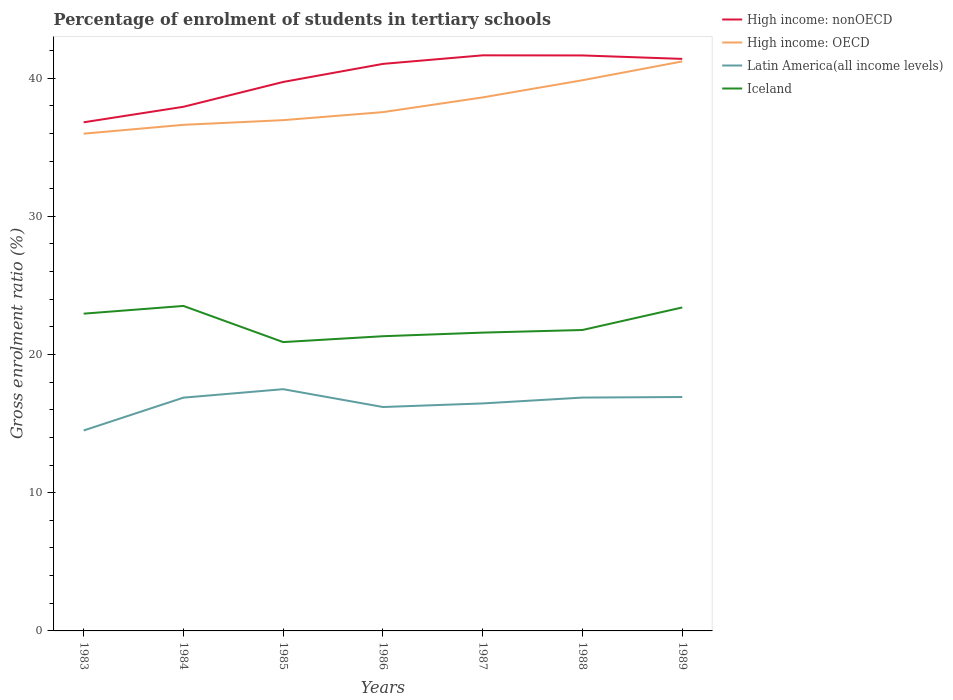Does the line corresponding to Iceland intersect with the line corresponding to High income: nonOECD?
Give a very brief answer. No. Is the number of lines equal to the number of legend labels?
Ensure brevity in your answer.  Yes. Across all years, what is the maximum percentage of students enrolled in tertiary schools in High income: nonOECD?
Your answer should be compact. 36.8. In which year was the percentage of students enrolled in tertiary schools in Iceland maximum?
Ensure brevity in your answer.  1985. What is the total percentage of students enrolled in tertiary schools in High income: OECD in the graph?
Make the answer very short. -0.92. What is the difference between the highest and the second highest percentage of students enrolled in tertiary schools in Latin America(all income levels)?
Your response must be concise. 2.99. How many years are there in the graph?
Your response must be concise. 7. Does the graph contain any zero values?
Your answer should be compact. No. Does the graph contain grids?
Give a very brief answer. No. What is the title of the graph?
Offer a very short reply. Percentage of enrolment of students in tertiary schools. What is the Gross enrolment ratio (%) of High income: nonOECD in 1983?
Give a very brief answer. 36.8. What is the Gross enrolment ratio (%) in High income: OECD in 1983?
Offer a very short reply. 35.98. What is the Gross enrolment ratio (%) in Latin America(all income levels) in 1983?
Offer a terse response. 14.5. What is the Gross enrolment ratio (%) of Iceland in 1983?
Offer a terse response. 22.96. What is the Gross enrolment ratio (%) in High income: nonOECD in 1984?
Your answer should be compact. 37.92. What is the Gross enrolment ratio (%) in High income: OECD in 1984?
Your answer should be very brief. 36.62. What is the Gross enrolment ratio (%) in Latin America(all income levels) in 1984?
Offer a very short reply. 16.88. What is the Gross enrolment ratio (%) of Iceland in 1984?
Provide a succinct answer. 23.51. What is the Gross enrolment ratio (%) of High income: nonOECD in 1985?
Keep it short and to the point. 39.72. What is the Gross enrolment ratio (%) of High income: OECD in 1985?
Make the answer very short. 36.96. What is the Gross enrolment ratio (%) of Latin America(all income levels) in 1985?
Make the answer very short. 17.49. What is the Gross enrolment ratio (%) of Iceland in 1985?
Make the answer very short. 20.9. What is the Gross enrolment ratio (%) of High income: nonOECD in 1986?
Your response must be concise. 41.03. What is the Gross enrolment ratio (%) of High income: OECD in 1986?
Provide a succinct answer. 37.54. What is the Gross enrolment ratio (%) in Latin America(all income levels) in 1986?
Offer a very short reply. 16.2. What is the Gross enrolment ratio (%) of Iceland in 1986?
Your response must be concise. 21.32. What is the Gross enrolment ratio (%) of High income: nonOECD in 1987?
Make the answer very short. 41.65. What is the Gross enrolment ratio (%) in High income: OECD in 1987?
Provide a succinct answer. 38.6. What is the Gross enrolment ratio (%) in Latin America(all income levels) in 1987?
Give a very brief answer. 16.46. What is the Gross enrolment ratio (%) in Iceland in 1987?
Your answer should be compact. 21.58. What is the Gross enrolment ratio (%) in High income: nonOECD in 1988?
Your answer should be very brief. 41.64. What is the Gross enrolment ratio (%) of High income: OECD in 1988?
Offer a terse response. 39.85. What is the Gross enrolment ratio (%) in Latin America(all income levels) in 1988?
Keep it short and to the point. 16.88. What is the Gross enrolment ratio (%) of Iceland in 1988?
Your answer should be very brief. 21.77. What is the Gross enrolment ratio (%) of High income: nonOECD in 1989?
Give a very brief answer. 41.39. What is the Gross enrolment ratio (%) of High income: OECD in 1989?
Your response must be concise. 41.21. What is the Gross enrolment ratio (%) of Latin America(all income levels) in 1989?
Give a very brief answer. 16.93. What is the Gross enrolment ratio (%) in Iceland in 1989?
Ensure brevity in your answer.  23.4. Across all years, what is the maximum Gross enrolment ratio (%) of High income: nonOECD?
Your answer should be compact. 41.65. Across all years, what is the maximum Gross enrolment ratio (%) in High income: OECD?
Keep it short and to the point. 41.21. Across all years, what is the maximum Gross enrolment ratio (%) in Latin America(all income levels)?
Your answer should be very brief. 17.49. Across all years, what is the maximum Gross enrolment ratio (%) in Iceland?
Give a very brief answer. 23.51. Across all years, what is the minimum Gross enrolment ratio (%) in High income: nonOECD?
Offer a very short reply. 36.8. Across all years, what is the minimum Gross enrolment ratio (%) of High income: OECD?
Provide a short and direct response. 35.98. Across all years, what is the minimum Gross enrolment ratio (%) in Latin America(all income levels)?
Offer a very short reply. 14.5. Across all years, what is the minimum Gross enrolment ratio (%) of Iceland?
Your answer should be very brief. 20.9. What is the total Gross enrolment ratio (%) of High income: nonOECD in the graph?
Provide a succinct answer. 280.15. What is the total Gross enrolment ratio (%) of High income: OECD in the graph?
Provide a short and direct response. 266.75. What is the total Gross enrolment ratio (%) of Latin America(all income levels) in the graph?
Make the answer very short. 115.35. What is the total Gross enrolment ratio (%) in Iceland in the graph?
Keep it short and to the point. 155.46. What is the difference between the Gross enrolment ratio (%) in High income: nonOECD in 1983 and that in 1984?
Offer a terse response. -1.12. What is the difference between the Gross enrolment ratio (%) in High income: OECD in 1983 and that in 1984?
Offer a very short reply. -0.64. What is the difference between the Gross enrolment ratio (%) of Latin America(all income levels) in 1983 and that in 1984?
Provide a short and direct response. -2.38. What is the difference between the Gross enrolment ratio (%) in Iceland in 1983 and that in 1984?
Make the answer very short. -0.56. What is the difference between the Gross enrolment ratio (%) of High income: nonOECD in 1983 and that in 1985?
Your answer should be very brief. -2.92. What is the difference between the Gross enrolment ratio (%) in High income: OECD in 1983 and that in 1985?
Ensure brevity in your answer.  -0.98. What is the difference between the Gross enrolment ratio (%) in Latin America(all income levels) in 1983 and that in 1985?
Ensure brevity in your answer.  -2.99. What is the difference between the Gross enrolment ratio (%) in Iceland in 1983 and that in 1985?
Provide a short and direct response. 2.06. What is the difference between the Gross enrolment ratio (%) of High income: nonOECD in 1983 and that in 1986?
Make the answer very short. -4.23. What is the difference between the Gross enrolment ratio (%) in High income: OECD in 1983 and that in 1986?
Provide a short and direct response. -1.56. What is the difference between the Gross enrolment ratio (%) of Latin America(all income levels) in 1983 and that in 1986?
Your answer should be compact. -1.7. What is the difference between the Gross enrolment ratio (%) of Iceland in 1983 and that in 1986?
Offer a terse response. 1.63. What is the difference between the Gross enrolment ratio (%) in High income: nonOECD in 1983 and that in 1987?
Your response must be concise. -4.85. What is the difference between the Gross enrolment ratio (%) of High income: OECD in 1983 and that in 1987?
Your answer should be very brief. -2.63. What is the difference between the Gross enrolment ratio (%) of Latin America(all income levels) in 1983 and that in 1987?
Your answer should be compact. -1.96. What is the difference between the Gross enrolment ratio (%) of Iceland in 1983 and that in 1987?
Offer a very short reply. 1.37. What is the difference between the Gross enrolment ratio (%) in High income: nonOECD in 1983 and that in 1988?
Provide a succinct answer. -4.84. What is the difference between the Gross enrolment ratio (%) of High income: OECD in 1983 and that in 1988?
Keep it short and to the point. -3.87. What is the difference between the Gross enrolment ratio (%) of Latin America(all income levels) in 1983 and that in 1988?
Your response must be concise. -2.38. What is the difference between the Gross enrolment ratio (%) of Iceland in 1983 and that in 1988?
Offer a very short reply. 1.18. What is the difference between the Gross enrolment ratio (%) of High income: nonOECD in 1983 and that in 1989?
Give a very brief answer. -4.59. What is the difference between the Gross enrolment ratio (%) of High income: OECD in 1983 and that in 1989?
Keep it short and to the point. -5.23. What is the difference between the Gross enrolment ratio (%) in Latin America(all income levels) in 1983 and that in 1989?
Provide a short and direct response. -2.42. What is the difference between the Gross enrolment ratio (%) in Iceland in 1983 and that in 1989?
Provide a short and direct response. -0.45. What is the difference between the Gross enrolment ratio (%) in High income: nonOECD in 1984 and that in 1985?
Offer a very short reply. -1.8. What is the difference between the Gross enrolment ratio (%) of High income: OECD in 1984 and that in 1985?
Offer a very short reply. -0.34. What is the difference between the Gross enrolment ratio (%) of Latin America(all income levels) in 1984 and that in 1985?
Your response must be concise. -0.61. What is the difference between the Gross enrolment ratio (%) in Iceland in 1984 and that in 1985?
Keep it short and to the point. 2.62. What is the difference between the Gross enrolment ratio (%) of High income: nonOECD in 1984 and that in 1986?
Provide a succinct answer. -3.1. What is the difference between the Gross enrolment ratio (%) of High income: OECD in 1984 and that in 1986?
Keep it short and to the point. -0.92. What is the difference between the Gross enrolment ratio (%) of Latin America(all income levels) in 1984 and that in 1986?
Your answer should be compact. 0.68. What is the difference between the Gross enrolment ratio (%) of Iceland in 1984 and that in 1986?
Provide a short and direct response. 2.19. What is the difference between the Gross enrolment ratio (%) in High income: nonOECD in 1984 and that in 1987?
Keep it short and to the point. -3.72. What is the difference between the Gross enrolment ratio (%) in High income: OECD in 1984 and that in 1987?
Make the answer very short. -1.98. What is the difference between the Gross enrolment ratio (%) of Latin America(all income levels) in 1984 and that in 1987?
Provide a succinct answer. 0.42. What is the difference between the Gross enrolment ratio (%) of Iceland in 1984 and that in 1987?
Provide a short and direct response. 1.93. What is the difference between the Gross enrolment ratio (%) in High income: nonOECD in 1984 and that in 1988?
Give a very brief answer. -3.72. What is the difference between the Gross enrolment ratio (%) of High income: OECD in 1984 and that in 1988?
Ensure brevity in your answer.  -3.23. What is the difference between the Gross enrolment ratio (%) of Latin America(all income levels) in 1984 and that in 1988?
Offer a very short reply. -0.01. What is the difference between the Gross enrolment ratio (%) of Iceland in 1984 and that in 1988?
Ensure brevity in your answer.  1.74. What is the difference between the Gross enrolment ratio (%) in High income: nonOECD in 1984 and that in 1989?
Provide a short and direct response. -3.47. What is the difference between the Gross enrolment ratio (%) in High income: OECD in 1984 and that in 1989?
Offer a very short reply. -4.59. What is the difference between the Gross enrolment ratio (%) of Latin America(all income levels) in 1984 and that in 1989?
Make the answer very short. -0.05. What is the difference between the Gross enrolment ratio (%) in Iceland in 1984 and that in 1989?
Ensure brevity in your answer.  0.11. What is the difference between the Gross enrolment ratio (%) in High income: nonOECD in 1985 and that in 1986?
Make the answer very short. -1.31. What is the difference between the Gross enrolment ratio (%) in High income: OECD in 1985 and that in 1986?
Your response must be concise. -0.58. What is the difference between the Gross enrolment ratio (%) of Latin America(all income levels) in 1985 and that in 1986?
Ensure brevity in your answer.  1.29. What is the difference between the Gross enrolment ratio (%) in Iceland in 1985 and that in 1986?
Offer a very short reply. -0.42. What is the difference between the Gross enrolment ratio (%) of High income: nonOECD in 1985 and that in 1987?
Offer a very short reply. -1.93. What is the difference between the Gross enrolment ratio (%) in High income: OECD in 1985 and that in 1987?
Make the answer very short. -1.65. What is the difference between the Gross enrolment ratio (%) of Latin America(all income levels) in 1985 and that in 1987?
Ensure brevity in your answer.  1.03. What is the difference between the Gross enrolment ratio (%) of Iceland in 1985 and that in 1987?
Offer a terse response. -0.69. What is the difference between the Gross enrolment ratio (%) of High income: nonOECD in 1985 and that in 1988?
Make the answer very short. -1.92. What is the difference between the Gross enrolment ratio (%) in High income: OECD in 1985 and that in 1988?
Your response must be concise. -2.89. What is the difference between the Gross enrolment ratio (%) of Latin America(all income levels) in 1985 and that in 1988?
Make the answer very short. 0.61. What is the difference between the Gross enrolment ratio (%) in Iceland in 1985 and that in 1988?
Keep it short and to the point. -0.87. What is the difference between the Gross enrolment ratio (%) in High income: nonOECD in 1985 and that in 1989?
Offer a very short reply. -1.67. What is the difference between the Gross enrolment ratio (%) of High income: OECD in 1985 and that in 1989?
Provide a succinct answer. -4.25. What is the difference between the Gross enrolment ratio (%) in Latin America(all income levels) in 1985 and that in 1989?
Keep it short and to the point. 0.57. What is the difference between the Gross enrolment ratio (%) of Iceland in 1985 and that in 1989?
Offer a terse response. -2.5. What is the difference between the Gross enrolment ratio (%) in High income: nonOECD in 1986 and that in 1987?
Make the answer very short. -0.62. What is the difference between the Gross enrolment ratio (%) of High income: OECD in 1986 and that in 1987?
Your answer should be very brief. -1.07. What is the difference between the Gross enrolment ratio (%) in Latin America(all income levels) in 1986 and that in 1987?
Provide a short and direct response. -0.26. What is the difference between the Gross enrolment ratio (%) of Iceland in 1986 and that in 1987?
Give a very brief answer. -0.26. What is the difference between the Gross enrolment ratio (%) in High income: nonOECD in 1986 and that in 1988?
Your answer should be very brief. -0.61. What is the difference between the Gross enrolment ratio (%) in High income: OECD in 1986 and that in 1988?
Provide a short and direct response. -2.31. What is the difference between the Gross enrolment ratio (%) in Latin America(all income levels) in 1986 and that in 1988?
Provide a short and direct response. -0.68. What is the difference between the Gross enrolment ratio (%) of Iceland in 1986 and that in 1988?
Offer a very short reply. -0.45. What is the difference between the Gross enrolment ratio (%) in High income: nonOECD in 1986 and that in 1989?
Ensure brevity in your answer.  -0.36. What is the difference between the Gross enrolment ratio (%) of High income: OECD in 1986 and that in 1989?
Ensure brevity in your answer.  -3.67. What is the difference between the Gross enrolment ratio (%) of Latin America(all income levels) in 1986 and that in 1989?
Give a very brief answer. -0.72. What is the difference between the Gross enrolment ratio (%) in Iceland in 1986 and that in 1989?
Offer a very short reply. -2.08. What is the difference between the Gross enrolment ratio (%) in High income: nonOECD in 1987 and that in 1988?
Offer a very short reply. 0.01. What is the difference between the Gross enrolment ratio (%) in High income: OECD in 1987 and that in 1988?
Your answer should be very brief. -1.24. What is the difference between the Gross enrolment ratio (%) in Latin America(all income levels) in 1987 and that in 1988?
Provide a succinct answer. -0.42. What is the difference between the Gross enrolment ratio (%) of Iceland in 1987 and that in 1988?
Your answer should be very brief. -0.19. What is the difference between the Gross enrolment ratio (%) of High income: nonOECD in 1987 and that in 1989?
Provide a succinct answer. 0.26. What is the difference between the Gross enrolment ratio (%) in High income: OECD in 1987 and that in 1989?
Offer a terse response. -2.6. What is the difference between the Gross enrolment ratio (%) in Latin America(all income levels) in 1987 and that in 1989?
Provide a succinct answer. -0.46. What is the difference between the Gross enrolment ratio (%) of Iceland in 1987 and that in 1989?
Offer a terse response. -1.82. What is the difference between the Gross enrolment ratio (%) of High income: nonOECD in 1988 and that in 1989?
Ensure brevity in your answer.  0.25. What is the difference between the Gross enrolment ratio (%) of High income: OECD in 1988 and that in 1989?
Offer a terse response. -1.36. What is the difference between the Gross enrolment ratio (%) of Latin America(all income levels) in 1988 and that in 1989?
Provide a succinct answer. -0.04. What is the difference between the Gross enrolment ratio (%) in Iceland in 1988 and that in 1989?
Provide a short and direct response. -1.63. What is the difference between the Gross enrolment ratio (%) in High income: nonOECD in 1983 and the Gross enrolment ratio (%) in High income: OECD in 1984?
Your response must be concise. 0.18. What is the difference between the Gross enrolment ratio (%) in High income: nonOECD in 1983 and the Gross enrolment ratio (%) in Latin America(all income levels) in 1984?
Offer a very short reply. 19.92. What is the difference between the Gross enrolment ratio (%) in High income: nonOECD in 1983 and the Gross enrolment ratio (%) in Iceland in 1984?
Provide a short and direct response. 13.29. What is the difference between the Gross enrolment ratio (%) in High income: OECD in 1983 and the Gross enrolment ratio (%) in Latin America(all income levels) in 1984?
Offer a very short reply. 19.1. What is the difference between the Gross enrolment ratio (%) in High income: OECD in 1983 and the Gross enrolment ratio (%) in Iceland in 1984?
Ensure brevity in your answer.  12.46. What is the difference between the Gross enrolment ratio (%) in Latin America(all income levels) in 1983 and the Gross enrolment ratio (%) in Iceland in 1984?
Your answer should be compact. -9.01. What is the difference between the Gross enrolment ratio (%) of High income: nonOECD in 1983 and the Gross enrolment ratio (%) of High income: OECD in 1985?
Provide a succinct answer. -0.16. What is the difference between the Gross enrolment ratio (%) of High income: nonOECD in 1983 and the Gross enrolment ratio (%) of Latin America(all income levels) in 1985?
Your answer should be compact. 19.31. What is the difference between the Gross enrolment ratio (%) in High income: nonOECD in 1983 and the Gross enrolment ratio (%) in Iceland in 1985?
Provide a succinct answer. 15.9. What is the difference between the Gross enrolment ratio (%) in High income: OECD in 1983 and the Gross enrolment ratio (%) in Latin America(all income levels) in 1985?
Offer a very short reply. 18.49. What is the difference between the Gross enrolment ratio (%) in High income: OECD in 1983 and the Gross enrolment ratio (%) in Iceland in 1985?
Provide a short and direct response. 15.08. What is the difference between the Gross enrolment ratio (%) in Latin America(all income levels) in 1983 and the Gross enrolment ratio (%) in Iceland in 1985?
Your response must be concise. -6.4. What is the difference between the Gross enrolment ratio (%) of High income: nonOECD in 1983 and the Gross enrolment ratio (%) of High income: OECD in 1986?
Ensure brevity in your answer.  -0.74. What is the difference between the Gross enrolment ratio (%) of High income: nonOECD in 1983 and the Gross enrolment ratio (%) of Latin America(all income levels) in 1986?
Your answer should be compact. 20.6. What is the difference between the Gross enrolment ratio (%) of High income: nonOECD in 1983 and the Gross enrolment ratio (%) of Iceland in 1986?
Offer a very short reply. 15.48. What is the difference between the Gross enrolment ratio (%) in High income: OECD in 1983 and the Gross enrolment ratio (%) in Latin America(all income levels) in 1986?
Keep it short and to the point. 19.78. What is the difference between the Gross enrolment ratio (%) of High income: OECD in 1983 and the Gross enrolment ratio (%) of Iceland in 1986?
Provide a succinct answer. 14.66. What is the difference between the Gross enrolment ratio (%) in Latin America(all income levels) in 1983 and the Gross enrolment ratio (%) in Iceland in 1986?
Offer a very short reply. -6.82. What is the difference between the Gross enrolment ratio (%) of High income: nonOECD in 1983 and the Gross enrolment ratio (%) of High income: OECD in 1987?
Your response must be concise. -1.8. What is the difference between the Gross enrolment ratio (%) in High income: nonOECD in 1983 and the Gross enrolment ratio (%) in Latin America(all income levels) in 1987?
Your response must be concise. 20.34. What is the difference between the Gross enrolment ratio (%) in High income: nonOECD in 1983 and the Gross enrolment ratio (%) in Iceland in 1987?
Provide a short and direct response. 15.22. What is the difference between the Gross enrolment ratio (%) in High income: OECD in 1983 and the Gross enrolment ratio (%) in Latin America(all income levels) in 1987?
Offer a very short reply. 19.52. What is the difference between the Gross enrolment ratio (%) of High income: OECD in 1983 and the Gross enrolment ratio (%) of Iceland in 1987?
Your answer should be compact. 14.39. What is the difference between the Gross enrolment ratio (%) of Latin America(all income levels) in 1983 and the Gross enrolment ratio (%) of Iceland in 1987?
Your response must be concise. -7.08. What is the difference between the Gross enrolment ratio (%) of High income: nonOECD in 1983 and the Gross enrolment ratio (%) of High income: OECD in 1988?
Provide a succinct answer. -3.04. What is the difference between the Gross enrolment ratio (%) in High income: nonOECD in 1983 and the Gross enrolment ratio (%) in Latin America(all income levels) in 1988?
Give a very brief answer. 19.92. What is the difference between the Gross enrolment ratio (%) in High income: nonOECD in 1983 and the Gross enrolment ratio (%) in Iceland in 1988?
Provide a short and direct response. 15.03. What is the difference between the Gross enrolment ratio (%) of High income: OECD in 1983 and the Gross enrolment ratio (%) of Latin America(all income levels) in 1988?
Your answer should be compact. 19.09. What is the difference between the Gross enrolment ratio (%) in High income: OECD in 1983 and the Gross enrolment ratio (%) in Iceland in 1988?
Your response must be concise. 14.21. What is the difference between the Gross enrolment ratio (%) of Latin America(all income levels) in 1983 and the Gross enrolment ratio (%) of Iceland in 1988?
Keep it short and to the point. -7.27. What is the difference between the Gross enrolment ratio (%) in High income: nonOECD in 1983 and the Gross enrolment ratio (%) in High income: OECD in 1989?
Keep it short and to the point. -4.41. What is the difference between the Gross enrolment ratio (%) of High income: nonOECD in 1983 and the Gross enrolment ratio (%) of Latin America(all income levels) in 1989?
Your answer should be very brief. 19.88. What is the difference between the Gross enrolment ratio (%) of High income: nonOECD in 1983 and the Gross enrolment ratio (%) of Iceland in 1989?
Provide a short and direct response. 13.4. What is the difference between the Gross enrolment ratio (%) in High income: OECD in 1983 and the Gross enrolment ratio (%) in Latin America(all income levels) in 1989?
Offer a very short reply. 19.05. What is the difference between the Gross enrolment ratio (%) of High income: OECD in 1983 and the Gross enrolment ratio (%) of Iceland in 1989?
Your answer should be compact. 12.57. What is the difference between the Gross enrolment ratio (%) of Latin America(all income levels) in 1983 and the Gross enrolment ratio (%) of Iceland in 1989?
Your response must be concise. -8.9. What is the difference between the Gross enrolment ratio (%) of High income: nonOECD in 1984 and the Gross enrolment ratio (%) of High income: OECD in 1985?
Give a very brief answer. 0.97. What is the difference between the Gross enrolment ratio (%) of High income: nonOECD in 1984 and the Gross enrolment ratio (%) of Latin America(all income levels) in 1985?
Offer a terse response. 20.43. What is the difference between the Gross enrolment ratio (%) in High income: nonOECD in 1984 and the Gross enrolment ratio (%) in Iceland in 1985?
Your answer should be very brief. 17.02. What is the difference between the Gross enrolment ratio (%) of High income: OECD in 1984 and the Gross enrolment ratio (%) of Latin America(all income levels) in 1985?
Ensure brevity in your answer.  19.13. What is the difference between the Gross enrolment ratio (%) in High income: OECD in 1984 and the Gross enrolment ratio (%) in Iceland in 1985?
Provide a short and direct response. 15.72. What is the difference between the Gross enrolment ratio (%) of Latin America(all income levels) in 1984 and the Gross enrolment ratio (%) of Iceland in 1985?
Provide a succinct answer. -4.02. What is the difference between the Gross enrolment ratio (%) of High income: nonOECD in 1984 and the Gross enrolment ratio (%) of High income: OECD in 1986?
Make the answer very short. 0.39. What is the difference between the Gross enrolment ratio (%) of High income: nonOECD in 1984 and the Gross enrolment ratio (%) of Latin America(all income levels) in 1986?
Offer a very short reply. 21.72. What is the difference between the Gross enrolment ratio (%) in High income: nonOECD in 1984 and the Gross enrolment ratio (%) in Iceland in 1986?
Ensure brevity in your answer.  16.6. What is the difference between the Gross enrolment ratio (%) in High income: OECD in 1984 and the Gross enrolment ratio (%) in Latin America(all income levels) in 1986?
Ensure brevity in your answer.  20.42. What is the difference between the Gross enrolment ratio (%) of High income: OECD in 1984 and the Gross enrolment ratio (%) of Iceland in 1986?
Make the answer very short. 15.3. What is the difference between the Gross enrolment ratio (%) of Latin America(all income levels) in 1984 and the Gross enrolment ratio (%) of Iceland in 1986?
Your answer should be very brief. -4.45. What is the difference between the Gross enrolment ratio (%) of High income: nonOECD in 1984 and the Gross enrolment ratio (%) of High income: OECD in 1987?
Your answer should be compact. -0.68. What is the difference between the Gross enrolment ratio (%) of High income: nonOECD in 1984 and the Gross enrolment ratio (%) of Latin America(all income levels) in 1987?
Provide a short and direct response. 21.46. What is the difference between the Gross enrolment ratio (%) in High income: nonOECD in 1984 and the Gross enrolment ratio (%) in Iceland in 1987?
Provide a short and direct response. 16.34. What is the difference between the Gross enrolment ratio (%) in High income: OECD in 1984 and the Gross enrolment ratio (%) in Latin America(all income levels) in 1987?
Give a very brief answer. 20.16. What is the difference between the Gross enrolment ratio (%) of High income: OECD in 1984 and the Gross enrolment ratio (%) of Iceland in 1987?
Your response must be concise. 15.03. What is the difference between the Gross enrolment ratio (%) in Latin America(all income levels) in 1984 and the Gross enrolment ratio (%) in Iceland in 1987?
Offer a very short reply. -4.71. What is the difference between the Gross enrolment ratio (%) in High income: nonOECD in 1984 and the Gross enrolment ratio (%) in High income: OECD in 1988?
Your response must be concise. -1.92. What is the difference between the Gross enrolment ratio (%) in High income: nonOECD in 1984 and the Gross enrolment ratio (%) in Latin America(all income levels) in 1988?
Your answer should be very brief. 21.04. What is the difference between the Gross enrolment ratio (%) in High income: nonOECD in 1984 and the Gross enrolment ratio (%) in Iceland in 1988?
Offer a very short reply. 16.15. What is the difference between the Gross enrolment ratio (%) in High income: OECD in 1984 and the Gross enrolment ratio (%) in Latin America(all income levels) in 1988?
Provide a succinct answer. 19.74. What is the difference between the Gross enrolment ratio (%) in High income: OECD in 1984 and the Gross enrolment ratio (%) in Iceland in 1988?
Give a very brief answer. 14.85. What is the difference between the Gross enrolment ratio (%) in Latin America(all income levels) in 1984 and the Gross enrolment ratio (%) in Iceland in 1988?
Your answer should be compact. -4.9. What is the difference between the Gross enrolment ratio (%) in High income: nonOECD in 1984 and the Gross enrolment ratio (%) in High income: OECD in 1989?
Provide a short and direct response. -3.28. What is the difference between the Gross enrolment ratio (%) of High income: nonOECD in 1984 and the Gross enrolment ratio (%) of Latin America(all income levels) in 1989?
Offer a terse response. 21. What is the difference between the Gross enrolment ratio (%) of High income: nonOECD in 1984 and the Gross enrolment ratio (%) of Iceland in 1989?
Ensure brevity in your answer.  14.52. What is the difference between the Gross enrolment ratio (%) of High income: OECD in 1984 and the Gross enrolment ratio (%) of Latin America(all income levels) in 1989?
Your response must be concise. 19.69. What is the difference between the Gross enrolment ratio (%) in High income: OECD in 1984 and the Gross enrolment ratio (%) in Iceland in 1989?
Keep it short and to the point. 13.22. What is the difference between the Gross enrolment ratio (%) of Latin America(all income levels) in 1984 and the Gross enrolment ratio (%) of Iceland in 1989?
Your response must be concise. -6.53. What is the difference between the Gross enrolment ratio (%) of High income: nonOECD in 1985 and the Gross enrolment ratio (%) of High income: OECD in 1986?
Offer a terse response. 2.18. What is the difference between the Gross enrolment ratio (%) in High income: nonOECD in 1985 and the Gross enrolment ratio (%) in Latin America(all income levels) in 1986?
Offer a terse response. 23.52. What is the difference between the Gross enrolment ratio (%) in High income: nonOECD in 1985 and the Gross enrolment ratio (%) in Iceland in 1986?
Offer a terse response. 18.4. What is the difference between the Gross enrolment ratio (%) in High income: OECD in 1985 and the Gross enrolment ratio (%) in Latin America(all income levels) in 1986?
Provide a short and direct response. 20.76. What is the difference between the Gross enrolment ratio (%) in High income: OECD in 1985 and the Gross enrolment ratio (%) in Iceland in 1986?
Keep it short and to the point. 15.63. What is the difference between the Gross enrolment ratio (%) of Latin America(all income levels) in 1985 and the Gross enrolment ratio (%) of Iceland in 1986?
Offer a terse response. -3.83. What is the difference between the Gross enrolment ratio (%) in High income: nonOECD in 1985 and the Gross enrolment ratio (%) in High income: OECD in 1987?
Provide a short and direct response. 1.12. What is the difference between the Gross enrolment ratio (%) of High income: nonOECD in 1985 and the Gross enrolment ratio (%) of Latin America(all income levels) in 1987?
Give a very brief answer. 23.26. What is the difference between the Gross enrolment ratio (%) in High income: nonOECD in 1985 and the Gross enrolment ratio (%) in Iceland in 1987?
Your answer should be compact. 18.14. What is the difference between the Gross enrolment ratio (%) of High income: OECD in 1985 and the Gross enrolment ratio (%) of Latin America(all income levels) in 1987?
Your answer should be compact. 20.5. What is the difference between the Gross enrolment ratio (%) of High income: OECD in 1985 and the Gross enrolment ratio (%) of Iceland in 1987?
Provide a succinct answer. 15.37. What is the difference between the Gross enrolment ratio (%) of Latin America(all income levels) in 1985 and the Gross enrolment ratio (%) of Iceland in 1987?
Offer a terse response. -4.09. What is the difference between the Gross enrolment ratio (%) of High income: nonOECD in 1985 and the Gross enrolment ratio (%) of High income: OECD in 1988?
Offer a terse response. -0.12. What is the difference between the Gross enrolment ratio (%) in High income: nonOECD in 1985 and the Gross enrolment ratio (%) in Latin America(all income levels) in 1988?
Offer a very short reply. 22.84. What is the difference between the Gross enrolment ratio (%) in High income: nonOECD in 1985 and the Gross enrolment ratio (%) in Iceland in 1988?
Provide a succinct answer. 17.95. What is the difference between the Gross enrolment ratio (%) in High income: OECD in 1985 and the Gross enrolment ratio (%) in Latin America(all income levels) in 1988?
Your answer should be very brief. 20.07. What is the difference between the Gross enrolment ratio (%) in High income: OECD in 1985 and the Gross enrolment ratio (%) in Iceland in 1988?
Offer a terse response. 15.18. What is the difference between the Gross enrolment ratio (%) of Latin America(all income levels) in 1985 and the Gross enrolment ratio (%) of Iceland in 1988?
Ensure brevity in your answer.  -4.28. What is the difference between the Gross enrolment ratio (%) of High income: nonOECD in 1985 and the Gross enrolment ratio (%) of High income: OECD in 1989?
Your response must be concise. -1.49. What is the difference between the Gross enrolment ratio (%) of High income: nonOECD in 1985 and the Gross enrolment ratio (%) of Latin America(all income levels) in 1989?
Your answer should be compact. 22.8. What is the difference between the Gross enrolment ratio (%) in High income: nonOECD in 1985 and the Gross enrolment ratio (%) in Iceland in 1989?
Your answer should be very brief. 16.32. What is the difference between the Gross enrolment ratio (%) in High income: OECD in 1985 and the Gross enrolment ratio (%) in Latin America(all income levels) in 1989?
Give a very brief answer. 20.03. What is the difference between the Gross enrolment ratio (%) of High income: OECD in 1985 and the Gross enrolment ratio (%) of Iceland in 1989?
Provide a short and direct response. 13.55. What is the difference between the Gross enrolment ratio (%) of Latin America(all income levels) in 1985 and the Gross enrolment ratio (%) of Iceland in 1989?
Your answer should be compact. -5.91. What is the difference between the Gross enrolment ratio (%) of High income: nonOECD in 1986 and the Gross enrolment ratio (%) of High income: OECD in 1987?
Your response must be concise. 2.42. What is the difference between the Gross enrolment ratio (%) of High income: nonOECD in 1986 and the Gross enrolment ratio (%) of Latin America(all income levels) in 1987?
Your response must be concise. 24.57. What is the difference between the Gross enrolment ratio (%) of High income: nonOECD in 1986 and the Gross enrolment ratio (%) of Iceland in 1987?
Your response must be concise. 19.44. What is the difference between the Gross enrolment ratio (%) in High income: OECD in 1986 and the Gross enrolment ratio (%) in Latin America(all income levels) in 1987?
Give a very brief answer. 21.08. What is the difference between the Gross enrolment ratio (%) of High income: OECD in 1986 and the Gross enrolment ratio (%) of Iceland in 1987?
Your answer should be very brief. 15.95. What is the difference between the Gross enrolment ratio (%) in Latin America(all income levels) in 1986 and the Gross enrolment ratio (%) in Iceland in 1987?
Offer a terse response. -5.38. What is the difference between the Gross enrolment ratio (%) of High income: nonOECD in 1986 and the Gross enrolment ratio (%) of High income: OECD in 1988?
Give a very brief answer. 1.18. What is the difference between the Gross enrolment ratio (%) in High income: nonOECD in 1986 and the Gross enrolment ratio (%) in Latin America(all income levels) in 1988?
Your answer should be compact. 24.14. What is the difference between the Gross enrolment ratio (%) in High income: nonOECD in 1986 and the Gross enrolment ratio (%) in Iceland in 1988?
Provide a short and direct response. 19.25. What is the difference between the Gross enrolment ratio (%) of High income: OECD in 1986 and the Gross enrolment ratio (%) of Latin America(all income levels) in 1988?
Keep it short and to the point. 20.65. What is the difference between the Gross enrolment ratio (%) of High income: OECD in 1986 and the Gross enrolment ratio (%) of Iceland in 1988?
Ensure brevity in your answer.  15.76. What is the difference between the Gross enrolment ratio (%) in Latin America(all income levels) in 1986 and the Gross enrolment ratio (%) in Iceland in 1988?
Your response must be concise. -5.57. What is the difference between the Gross enrolment ratio (%) of High income: nonOECD in 1986 and the Gross enrolment ratio (%) of High income: OECD in 1989?
Provide a short and direct response. -0.18. What is the difference between the Gross enrolment ratio (%) of High income: nonOECD in 1986 and the Gross enrolment ratio (%) of Latin America(all income levels) in 1989?
Your answer should be very brief. 24.1. What is the difference between the Gross enrolment ratio (%) in High income: nonOECD in 1986 and the Gross enrolment ratio (%) in Iceland in 1989?
Provide a succinct answer. 17.62. What is the difference between the Gross enrolment ratio (%) of High income: OECD in 1986 and the Gross enrolment ratio (%) of Latin America(all income levels) in 1989?
Keep it short and to the point. 20.61. What is the difference between the Gross enrolment ratio (%) in High income: OECD in 1986 and the Gross enrolment ratio (%) in Iceland in 1989?
Your answer should be compact. 14.13. What is the difference between the Gross enrolment ratio (%) of Latin America(all income levels) in 1986 and the Gross enrolment ratio (%) of Iceland in 1989?
Your answer should be compact. -7.2. What is the difference between the Gross enrolment ratio (%) in High income: nonOECD in 1987 and the Gross enrolment ratio (%) in High income: OECD in 1988?
Your answer should be very brief. 1.8. What is the difference between the Gross enrolment ratio (%) of High income: nonOECD in 1987 and the Gross enrolment ratio (%) of Latin America(all income levels) in 1988?
Make the answer very short. 24.76. What is the difference between the Gross enrolment ratio (%) of High income: nonOECD in 1987 and the Gross enrolment ratio (%) of Iceland in 1988?
Keep it short and to the point. 19.87. What is the difference between the Gross enrolment ratio (%) of High income: OECD in 1987 and the Gross enrolment ratio (%) of Latin America(all income levels) in 1988?
Offer a terse response. 21.72. What is the difference between the Gross enrolment ratio (%) of High income: OECD in 1987 and the Gross enrolment ratio (%) of Iceland in 1988?
Keep it short and to the point. 16.83. What is the difference between the Gross enrolment ratio (%) in Latin America(all income levels) in 1987 and the Gross enrolment ratio (%) in Iceland in 1988?
Provide a succinct answer. -5.31. What is the difference between the Gross enrolment ratio (%) of High income: nonOECD in 1987 and the Gross enrolment ratio (%) of High income: OECD in 1989?
Your answer should be very brief. 0.44. What is the difference between the Gross enrolment ratio (%) in High income: nonOECD in 1987 and the Gross enrolment ratio (%) in Latin America(all income levels) in 1989?
Make the answer very short. 24.72. What is the difference between the Gross enrolment ratio (%) in High income: nonOECD in 1987 and the Gross enrolment ratio (%) in Iceland in 1989?
Make the answer very short. 18.24. What is the difference between the Gross enrolment ratio (%) in High income: OECD in 1987 and the Gross enrolment ratio (%) in Latin America(all income levels) in 1989?
Your answer should be very brief. 21.68. What is the difference between the Gross enrolment ratio (%) of High income: OECD in 1987 and the Gross enrolment ratio (%) of Iceland in 1989?
Offer a very short reply. 15.2. What is the difference between the Gross enrolment ratio (%) of Latin America(all income levels) in 1987 and the Gross enrolment ratio (%) of Iceland in 1989?
Keep it short and to the point. -6.94. What is the difference between the Gross enrolment ratio (%) in High income: nonOECD in 1988 and the Gross enrolment ratio (%) in High income: OECD in 1989?
Provide a short and direct response. 0.43. What is the difference between the Gross enrolment ratio (%) of High income: nonOECD in 1988 and the Gross enrolment ratio (%) of Latin America(all income levels) in 1989?
Offer a very short reply. 24.72. What is the difference between the Gross enrolment ratio (%) in High income: nonOECD in 1988 and the Gross enrolment ratio (%) in Iceland in 1989?
Provide a short and direct response. 18.24. What is the difference between the Gross enrolment ratio (%) of High income: OECD in 1988 and the Gross enrolment ratio (%) of Latin America(all income levels) in 1989?
Provide a short and direct response. 22.92. What is the difference between the Gross enrolment ratio (%) in High income: OECD in 1988 and the Gross enrolment ratio (%) in Iceland in 1989?
Your response must be concise. 16.44. What is the difference between the Gross enrolment ratio (%) of Latin America(all income levels) in 1988 and the Gross enrolment ratio (%) of Iceland in 1989?
Provide a short and direct response. -6.52. What is the average Gross enrolment ratio (%) in High income: nonOECD per year?
Your answer should be compact. 40.02. What is the average Gross enrolment ratio (%) in High income: OECD per year?
Ensure brevity in your answer.  38.11. What is the average Gross enrolment ratio (%) in Latin America(all income levels) per year?
Offer a very short reply. 16.48. What is the average Gross enrolment ratio (%) of Iceland per year?
Ensure brevity in your answer.  22.21. In the year 1983, what is the difference between the Gross enrolment ratio (%) of High income: nonOECD and Gross enrolment ratio (%) of High income: OECD?
Make the answer very short. 0.82. In the year 1983, what is the difference between the Gross enrolment ratio (%) in High income: nonOECD and Gross enrolment ratio (%) in Latin America(all income levels)?
Ensure brevity in your answer.  22.3. In the year 1983, what is the difference between the Gross enrolment ratio (%) in High income: nonOECD and Gross enrolment ratio (%) in Iceland?
Ensure brevity in your answer.  13.85. In the year 1983, what is the difference between the Gross enrolment ratio (%) of High income: OECD and Gross enrolment ratio (%) of Latin America(all income levels)?
Ensure brevity in your answer.  21.48. In the year 1983, what is the difference between the Gross enrolment ratio (%) in High income: OECD and Gross enrolment ratio (%) in Iceland?
Keep it short and to the point. 13.02. In the year 1983, what is the difference between the Gross enrolment ratio (%) of Latin America(all income levels) and Gross enrolment ratio (%) of Iceland?
Your response must be concise. -8.45. In the year 1984, what is the difference between the Gross enrolment ratio (%) in High income: nonOECD and Gross enrolment ratio (%) in High income: OECD?
Your answer should be compact. 1.3. In the year 1984, what is the difference between the Gross enrolment ratio (%) of High income: nonOECD and Gross enrolment ratio (%) of Latin America(all income levels)?
Your response must be concise. 21.05. In the year 1984, what is the difference between the Gross enrolment ratio (%) of High income: nonOECD and Gross enrolment ratio (%) of Iceland?
Your response must be concise. 14.41. In the year 1984, what is the difference between the Gross enrolment ratio (%) in High income: OECD and Gross enrolment ratio (%) in Latin America(all income levels)?
Offer a very short reply. 19.74. In the year 1984, what is the difference between the Gross enrolment ratio (%) of High income: OECD and Gross enrolment ratio (%) of Iceland?
Give a very brief answer. 13.11. In the year 1984, what is the difference between the Gross enrolment ratio (%) of Latin America(all income levels) and Gross enrolment ratio (%) of Iceland?
Offer a terse response. -6.64. In the year 1985, what is the difference between the Gross enrolment ratio (%) of High income: nonOECD and Gross enrolment ratio (%) of High income: OECD?
Make the answer very short. 2.76. In the year 1985, what is the difference between the Gross enrolment ratio (%) in High income: nonOECD and Gross enrolment ratio (%) in Latin America(all income levels)?
Make the answer very short. 22.23. In the year 1985, what is the difference between the Gross enrolment ratio (%) in High income: nonOECD and Gross enrolment ratio (%) in Iceland?
Provide a succinct answer. 18.82. In the year 1985, what is the difference between the Gross enrolment ratio (%) in High income: OECD and Gross enrolment ratio (%) in Latin America(all income levels)?
Provide a short and direct response. 19.47. In the year 1985, what is the difference between the Gross enrolment ratio (%) in High income: OECD and Gross enrolment ratio (%) in Iceland?
Offer a very short reply. 16.06. In the year 1985, what is the difference between the Gross enrolment ratio (%) of Latin America(all income levels) and Gross enrolment ratio (%) of Iceland?
Your response must be concise. -3.41. In the year 1986, what is the difference between the Gross enrolment ratio (%) of High income: nonOECD and Gross enrolment ratio (%) of High income: OECD?
Your answer should be very brief. 3.49. In the year 1986, what is the difference between the Gross enrolment ratio (%) of High income: nonOECD and Gross enrolment ratio (%) of Latin America(all income levels)?
Offer a terse response. 24.83. In the year 1986, what is the difference between the Gross enrolment ratio (%) in High income: nonOECD and Gross enrolment ratio (%) in Iceland?
Your response must be concise. 19.71. In the year 1986, what is the difference between the Gross enrolment ratio (%) of High income: OECD and Gross enrolment ratio (%) of Latin America(all income levels)?
Your response must be concise. 21.34. In the year 1986, what is the difference between the Gross enrolment ratio (%) in High income: OECD and Gross enrolment ratio (%) in Iceland?
Your answer should be compact. 16.21. In the year 1986, what is the difference between the Gross enrolment ratio (%) of Latin America(all income levels) and Gross enrolment ratio (%) of Iceland?
Ensure brevity in your answer.  -5.12. In the year 1987, what is the difference between the Gross enrolment ratio (%) of High income: nonOECD and Gross enrolment ratio (%) of High income: OECD?
Provide a short and direct response. 3.04. In the year 1987, what is the difference between the Gross enrolment ratio (%) of High income: nonOECD and Gross enrolment ratio (%) of Latin America(all income levels)?
Your response must be concise. 25.19. In the year 1987, what is the difference between the Gross enrolment ratio (%) in High income: nonOECD and Gross enrolment ratio (%) in Iceland?
Your response must be concise. 20.06. In the year 1987, what is the difference between the Gross enrolment ratio (%) in High income: OECD and Gross enrolment ratio (%) in Latin America(all income levels)?
Provide a short and direct response. 22.14. In the year 1987, what is the difference between the Gross enrolment ratio (%) of High income: OECD and Gross enrolment ratio (%) of Iceland?
Your answer should be compact. 17.02. In the year 1987, what is the difference between the Gross enrolment ratio (%) in Latin America(all income levels) and Gross enrolment ratio (%) in Iceland?
Offer a terse response. -5.12. In the year 1988, what is the difference between the Gross enrolment ratio (%) in High income: nonOECD and Gross enrolment ratio (%) in High income: OECD?
Keep it short and to the point. 1.79. In the year 1988, what is the difference between the Gross enrolment ratio (%) of High income: nonOECD and Gross enrolment ratio (%) of Latin America(all income levels)?
Give a very brief answer. 24.76. In the year 1988, what is the difference between the Gross enrolment ratio (%) of High income: nonOECD and Gross enrolment ratio (%) of Iceland?
Provide a succinct answer. 19.87. In the year 1988, what is the difference between the Gross enrolment ratio (%) in High income: OECD and Gross enrolment ratio (%) in Latin America(all income levels)?
Offer a very short reply. 22.96. In the year 1988, what is the difference between the Gross enrolment ratio (%) of High income: OECD and Gross enrolment ratio (%) of Iceland?
Give a very brief answer. 18.07. In the year 1988, what is the difference between the Gross enrolment ratio (%) in Latin America(all income levels) and Gross enrolment ratio (%) in Iceland?
Your response must be concise. -4.89. In the year 1989, what is the difference between the Gross enrolment ratio (%) in High income: nonOECD and Gross enrolment ratio (%) in High income: OECD?
Your answer should be compact. 0.18. In the year 1989, what is the difference between the Gross enrolment ratio (%) of High income: nonOECD and Gross enrolment ratio (%) of Latin America(all income levels)?
Offer a terse response. 24.47. In the year 1989, what is the difference between the Gross enrolment ratio (%) of High income: nonOECD and Gross enrolment ratio (%) of Iceland?
Keep it short and to the point. 17.99. In the year 1989, what is the difference between the Gross enrolment ratio (%) of High income: OECD and Gross enrolment ratio (%) of Latin America(all income levels)?
Ensure brevity in your answer.  24.28. In the year 1989, what is the difference between the Gross enrolment ratio (%) in High income: OECD and Gross enrolment ratio (%) in Iceland?
Ensure brevity in your answer.  17.8. In the year 1989, what is the difference between the Gross enrolment ratio (%) in Latin America(all income levels) and Gross enrolment ratio (%) in Iceland?
Your response must be concise. -6.48. What is the ratio of the Gross enrolment ratio (%) in High income: nonOECD in 1983 to that in 1984?
Make the answer very short. 0.97. What is the ratio of the Gross enrolment ratio (%) in High income: OECD in 1983 to that in 1984?
Give a very brief answer. 0.98. What is the ratio of the Gross enrolment ratio (%) in Latin America(all income levels) in 1983 to that in 1984?
Give a very brief answer. 0.86. What is the ratio of the Gross enrolment ratio (%) of Iceland in 1983 to that in 1984?
Provide a succinct answer. 0.98. What is the ratio of the Gross enrolment ratio (%) of High income: nonOECD in 1983 to that in 1985?
Give a very brief answer. 0.93. What is the ratio of the Gross enrolment ratio (%) of High income: OECD in 1983 to that in 1985?
Ensure brevity in your answer.  0.97. What is the ratio of the Gross enrolment ratio (%) of Latin America(all income levels) in 1983 to that in 1985?
Provide a succinct answer. 0.83. What is the ratio of the Gross enrolment ratio (%) in Iceland in 1983 to that in 1985?
Provide a short and direct response. 1.1. What is the ratio of the Gross enrolment ratio (%) in High income: nonOECD in 1983 to that in 1986?
Make the answer very short. 0.9. What is the ratio of the Gross enrolment ratio (%) of High income: OECD in 1983 to that in 1986?
Provide a succinct answer. 0.96. What is the ratio of the Gross enrolment ratio (%) of Latin America(all income levels) in 1983 to that in 1986?
Provide a short and direct response. 0.9. What is the ratio of the Gross enrolment ratio (%) of Iceland in 1983 to that in 1986?
Keep it short and to the point. 1.08. What is the ratio of the Gross enrolment ratio (%) in High income: nonOECD in 1983 to that in 1987?
Provide a succinct answer. 0.88. What is the ratio of the Gross enrolment ratio (%) of High income: OECD in 1983 to that in 1987?
Your answer should be very brief. 0.93. What is the ratio of the Gross enrolment ratio (%) of Latin America(all income levels) in 1983 to that in 1987?
Keep it short and to the point. 0.88. What is the ratio of the Gross enrolment ratio (%) of Iceland in 1983 to that in 1987?
Offer a terse response. 1.06. What is the ratio of the Gross enrolment ratio (%) of High income: nonOECD in 1983 to that in 1988?
Your response must be concise. 0.88. What is the ratio of the Gross enrolment ratio (%) in High income: OECD in 1983 to that in 1988?
Your answer should be very brief. 0.9. What is the ratio of the Gross enrolment ratio (%) of Latin America(all income levels) in 1983 to that in 1988?
Provide a succinct answer. 0.86. What is the ratio of the Gross enrolment ratio (%) of Iceland in 1983 to that in 1988?
Your answer should be very brief. 1.05. What is the ratio of the Gross enrolment ratio (%) of High income: nonOECD in 1983 to that in 1989?
Provide a succinct answer. 0.89. What is the ratio of the Gross enrolment ratio (%) in High income: OECD in 1983 to that in 1989?
Keep it short and to the point. 0.87. What is the ratio of the Gross enrolment ratio (%) in Latin America(all income levels) in 1983 to that in 1989?
Give a very brief answer. 0.86. What is the ratio of the Gross enrolment ratio (%) of Iceland in 1983 to that in 1989?
Your response must be concise. 0.98. What is the ratio of the Gross enrolment ratio (%) in High income: nonOECD in 1984 to that in 1985?
Ensure brevity in your answer.  0.95. What is the ratio of the Gross enrolment ratio (%) of High income: OECD in 1984 to that in 1985?
Your response must be concise. 0.99. What is the ratio of the Gross enrolment ratio (%) of Latin America(all income levels) in 1984 to that in 1985?
Give a very brief answer. 0.96. What is the ratio of the Gross enrolment ratio (%) of Iceland in 1984 to that in 1985?
Offer a very short reply. 1.13. What is the ratio of the Gross enrolment ratio (%) of High income: nonOECD in 1984 to that in 1986?
Your answer should be very brief. 0.92. What is the ratio of the Gross enrolment ratio (%) of High income: OECD in 1984 to that in 1986?
Make the answer very short. 0.98. What is the ratio of the Gross enrolment ratio (%) of Latin America(all income levels) in 1984 to that in 1986?
Your answer should be compact. 1.04. What is the ratio of the Gross enrolment ratio (%) of Iceland in 1984 to that in 1986?
Provide a short and direct response. 1.1. What is the ratio of the Gross enrolment ratio (%) of High income: nonOECD in 1984 to that in 1987?
Provide a succinct answer. 0.91. What is the ratio of the Gross enrolment ratio (%) of High income: OECD in 1984 to that in 1987?
Offer a very short reply. 0.95. What is the ratio of the Gross enrolment ratio (%) in Latin America(all income levels) in 1984 to that in 1987?
Ensure brevity in your answer.  1.03. What is the ratio of the Gross enrolment ratio (%) of Iceland in 1984 to that in 1987?
Offer a terse response. 1.09. What is the ratio of the Gross enrolment ratio (%) in High income: nonOECD in 1984 to that in 1988?
Your answer should be very brief. 0.91. What is the ratio of the Gross enrolment ratio (%) in High income: OECD in 1984 to that in 1988?
Provide a succinct answer. 0.92. What is the ratio of the Gross enrolment ratio (%) in Latin America(all income levels) in 1984 to that in 1988?
Your response must be concise. 1. What is the ratio of the Gross enrolment ratio (%) of Iceland in 1984 to that in 1988?
Give a very brief answer. 1.08. What is the ratio of the Gross enrolment ratio (%) in High income: nonOECD in 1984 to that in 1989?
Your response must be concise. 0.92. What is the ratio of the Gross enrolment ratio (%) of High income: OECD in 1984 to that in 1989?
Provide a succinct answer. 0.89. What is the ratio of the Gross enrolment ratio (%) of Iceland in 1984 to that in 1989?
Your response must be concise. 1. What is the ratio of the Gross enrolment ratio (%) of High income: nonOECD in 1985 to that in 1986?
Your answer should be compact. 0.97. What is the ratio of the Gross enrolment ratio (%) in High income: OECD in 1985 to that in 1986?
Keep it short and to the point. 0.98. What is the ratio of the Gross enrolment ratio (%) of Latin America(all income levels) in 1985 to that in 1986?
Make the answer very short. 1.08. What is the ratio of the Gross enrolment ratio (%) in Iceland in 1985 to that in 1986?
Offer a very short reply. 0.98. What is the ratio of the Gross enrolment ratio (%) of High income: nonOECD in 1985 to that in 1987?
Your answer should be very brief. 0.95. What is the ratio of the Gross enrolment ratio (%) in High income: OECD in 1985 to that in 1987?
Your answer should be very brief. 0.96. What is the ratio of the Gross enrolment ratio (%) in Latin America(all income levels) in 1985 to that in 1987?
Provide a succinct answer. 1.06. What is the ratio of the Gross enrolment ratio (%) in Iceland in 1985 to that in 1987?
Provide a short and direct response. 0.97. What is the ratio of the Gross enrolment ratio (%) in High income: nonOECD in 1985 to that in 1988?
Ensure brevity in your answer.  0.95. What is the ratio of the Gross enrolment ratio (%) of High income: OECD in 1985 to that in 1988?
Your response must be concise. 0.93. What is the ratio of the Gross enrolment ratio (%) of Latin America(all income levels) in 1985 to that in 1988?
Make the answer very short. 1.04. What is the ratio of the Gross enrolment ratio (%) of Iceland in 1985 to that in 1988?
Your response must be concise. 0.96. What is the ratio of the Gross enrolment ratio (%) in High income: nonOECD in 1985 to that in 1989?
Your response must be concise. 0.96. What is the ratio of the Gross enrolment ratio (%) in High income: OECD in 1985 to that in 1989?
Your response must be concise. 0.9. What is the ratio of the Gross enrolment ratio (%) of Latin America(all income levels) in 1985 to that in 1989?
Provide a short and direct response. 1.03. What is the ratio of the Gross enrolment ratio (%) in Iceland in 1985 to that in 1989?
Make the answer very short. 0.89. What is the ratio of the Gross enrolment ratio (%) of High income: nonOECD in 1986 to that in 1987?
Provide a short and direct response. 0.99. What is the ratio of the Gross enrolment ratio (%) in High income: OECD in 1986 to that in 1987?
Offer a very short reply. 0.97. What is the ratio of the Gross enrolment ratio (%) of Latin America(all income levels) in 1986 to that in 1987?
Your response must be concise. 0.98. What is the ratio of the Gross enrolment ratio (%) in Iceland in 1986 to that in 1987?
Make the answer very short. 0.99. What is the ratio of the Gross enrolment ratio (%) in High income: nonOECD in 1986 to that in 1988?
Provide a short and direct response. 0.99. What is the ratio of the Gross enrolment ratio (%) in High income: OECD in 1986 to that in 1988?
Offer a terse response. 0.94. What is the ratio of the Gross enrolment ratio (%) in Latin America(all income levels) in 1986 to that in 1988?
Make the answer very short. 0.96. What is the ratio of the Gross enrolment ratio (%) in Iceland in 1986 to that in 1988?
Your response must be concise. 0.98. What is the ratio of the Gross enrolment ratio (%) of High income: OECD in 1986 to that in 1989?
Your response must be concise. 0.91. What is the ratio of the Gross enrolment ratio (%) of Latin America(all income levels) in 1986 to that in 1989?
Your answer should be compact. 0.96. What is the ratio of the Gross enrolment ratio (%) in Iceland in 1986 to that in 1989?
Offer a terse response. 0.91. What is the ratio of the Gross enrolment ratio (%) in High income: OECD in 1987 to that in 1988?
Give a very brief answer. 0.97. What is the ratio of the Gross enrolment ratio (%) in Latin America(all income levels) in 1987 to that in 1988?
Make the answer very short. 0.97. What is the ratio of the Gross enrolment ratio (%) in High income: nonOECD in 1987 to that in 1989?
Keep it short and to the point. 1.01. What is the ratio of the Gross enrolment ratio (%) in High income: OECD in 1987 to that in 1989?
Offer a terse response. 0.94. What is the ratio of the Gross enrolment ratio (%) in Latin America(all income levels) in 1987 to that in 1989?
Your answer should be compact. 0.97. What is the ratio of the Gross enrolment ratio (%) of Iceland in 1987 to that in 1989?
Provide a succinct answer. 0.92. What is the ratio of the Gross enrolment ratio (%) in Iceland in 1988 to that in 1989?
Give a very brief answer. 0.93. What is the difference between the highest and the second highest Gross enrolment ratio (%) in High income: nonOECD?
Keep it short and to the point. 0.01. What is the difference between the highest and the second highest Gross enrolment ratio (%) in High income: OECD?
Make the answer very short. 1.36. What is the difference between the highest and the second highest Gross enrolment ratio (%) in Latin America(all income levels)?
Your answer should be compact. 0.57. What is the difference between the highest and the second highest Gross enrolment ratio (%) of Iceland?
Keep it short and to the point. 0.11. What is the difference between the highest and the lowest Gross enrolment ratio (%) of High income: nonOECD?
Provide a short and direct response. 4.85. What is the difference between the highest and the lowest Gross enrolment ratio (%) of High income: OECD?
Your answer should be compact. 5.23. What is the difference between the highest and the lowest Gross enrolment ratio (%) in Latin America(all income levels)?
Provide a short and direct response. 2.99. What is the difference between the highest and the lowest Gross enrolment ratio (%) in Iceland?
Your response must be concise. 2.62. 